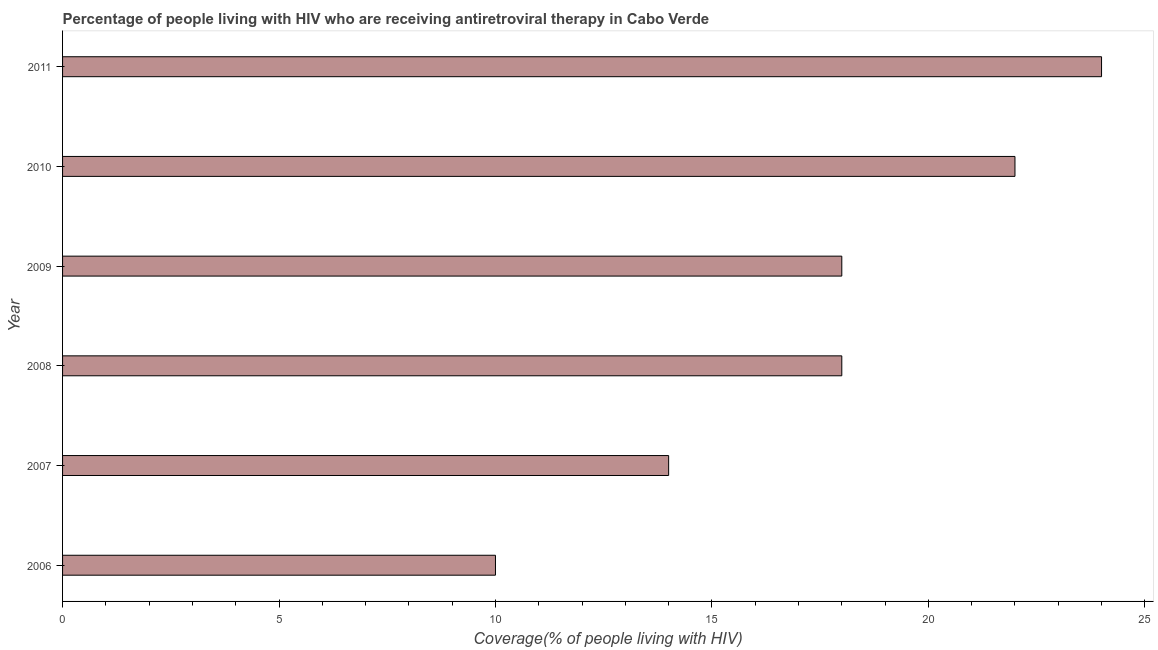What is the title of the graph?
Offer a very short reply. Percentage of people living with HIV who are receiving antiretroviral therapy in Cabo Verde. What is the label or title of the X-axis?
Ensure brevity in your answer.  Coverage(% of people living with HIV). What is the antiretroviral therapy coverage in 2008?
Provide a succinct answer. 18. Across all years, what is the maximum antiretroviral therapy coverage?
Offer a terse response. 24. In which year was the antiretroviral therapy coverage minimum?
Make the answer very short. 2006. What is the sum of the antiretroviral therapy coverage?
Provide a short and direct response. 106. What is the difference between the antiretroviral therapy coverage in 2006 and 2011?
Give a very brief answer. -14. What is the average antiretroviral therapy coverage per year?
Your response must be concise. 17. In how many years, is the antiretroviral therapy coverage greater than 10 %?
Keep it short and to the point. 5. Do a majority of the years between 2011 and 2010 (inclusive) have antiretroviral therapy coverage greater than 3 %?
Offer a very short reply. No. What is the ratio of the antiretroviral therapy coverage in 2007 to that in 2010?
Ensure brevity in your answer.  0.64. Is the antiretroviral therapy coverage in 2008 less than that in 2011?
Provide a succinct answer. Yes. Is the sum of the antiretroviral therapy coverage in 2007 and 2008 greater than the maximum antiretroviral therapy coverage across all years?
Keep it short and to the point. Yes. What is the difference between the highest and the lowest antiretroviral therapy coverage?
Offer a very short reply. 14. In how many years, is the antiretroviral therapy coverage greater than the average antiretroviral therapy coverage taken over all years?
Provide a short and direct response. 4. How many years are there in the graph?
Provide a short and direct response. 6. What is the Coverage(% of people living with HIV) in 2006?
Ensure brevity in your answer.  10. What is the Coverage(% of people living with HIV) of 2008?
Ensure brevity in your answer.  18. What is the Coverage(% of people living with HIV) in 2009?
Your response must be concise. 18. What is the Coverage(% of people living with HIV) of 2011?
Offer a terse response. 24. What is the difference between the Coverage(% of people living with HIV) in 2006 and 2007?
Make the answer very short. -4. What is the difference between the Coverage(% of people living with HIV) in 2007 and 2010?
Ensure brevity in your answer.  -8. What is the difference between the Coverage(% of people living with HIV) in 2007 and 2011?
Offer a very short reply. -10. What is the difference between the Coverage(% of people living with HIV) in 2008 and 2009?
Your response must be concise. 0. What is the difference between the Coverage(% of people living with HIV) in 2008 and 2010?
Your answer should be compact. -4. What is the difference between the Coverage(% of people living with HIV) in 2008 and 2011?
Keep it short and to the point. -6. What is the difference between the Coverage(% of people living with HIV) in 2009 and 2010?
Your answer should be compact. -4. What is the difference between the Coverage(% of people living with HIV) in 2009 and 2011?
Make the answer very short. -6. What is the ratio of the Coverage(% of people living with HIV) in 2006 to that in 2007?
Make the answer very short. 0.71. What is the ratio of the Coverage(% of people living with HIV) in 2006 to that in 2008?
Your response must be concise. 0.56. What is the ratio of the Coverage(% of people living with HIV) in 2006 to that in 2009?
Your response must be concise. 0.56. What is the ratio of the Coverage(% of people living with HIV) in 2006 to that in 2010?
Your answer should be very brief. 0.46. What is the ratio of the Coverage(% of people living with HIV) in 2006 to that in 2011?
Keep it short and to the point. 0.42. What is the ratio of the Coverage(% of people living with HIV) in 2007 to that in 2008?
Ensure brevity in your answer.  0.78. What is the ratio of the Coverage(% of people living with HIV) in 2007 to that in 2009?
Provide a short and direct response. 0.78. What is the ratio of the Coverage(% of people living with HIV) in 2007 to that in 2010?
Offer a very short reply. 0.64. What is the ratio of the Coverage(% of people living with HIV) in 2007 to that in 2011?
Make the answer very short. 0.58. What is the ratio of the Coverage(% of people living with HIV) in 2008 to that in 2009?
Give a very brief answer. 1. What is the ratio of the Coverage(% of people living with HIV) in 2008 to that in 2010?
Your answer should be compact. 0.82. What is the ratio of the Coverage(% of people living with HIV) in 2008 to that in 2011?
Ensure brevity in your answer.  0.75. What is the ratio of the Coverage(% of people living with HIV) in 2009 to that in 2010?
Offer a terse response. 0.82. What is the ratio of the Coverage(% of people living with HIV) in 2009 to that in 2011?
Keep it short and to the point. 0.75. What is the ratio of the Coverage(% of people living with HIV) in 2010 to that in 2011?
Give a very brief answer. 0.92. 